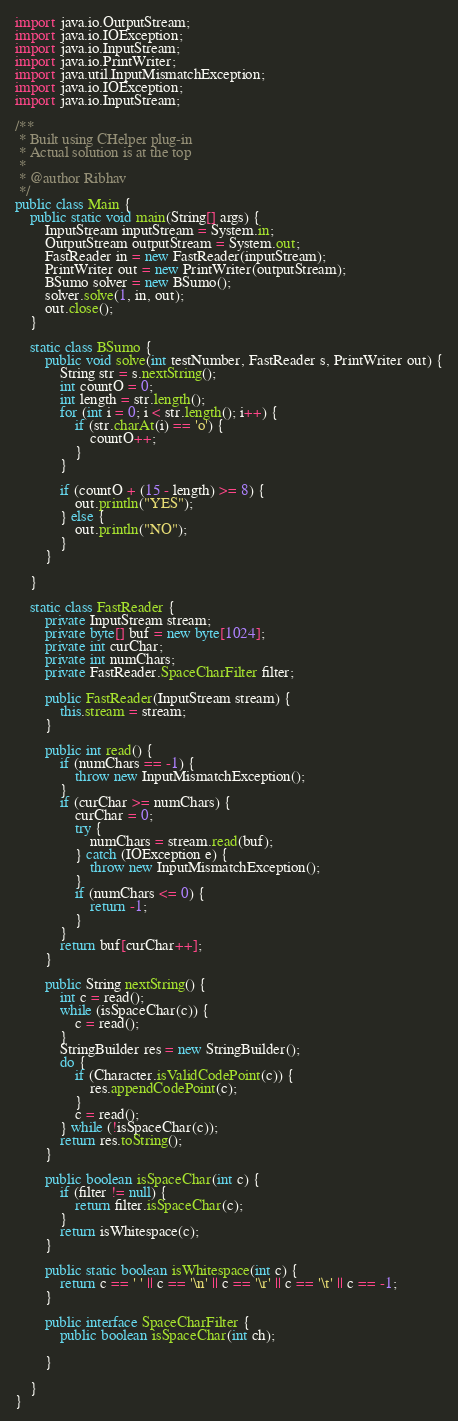Convert code to text. <code><loc_0><loc_0><loc_500><loc_500><_Java_>import java.io.OutputStream;
import java.io.IOException;
import java.io.InputStream;
import java.io.PrintWriter;
import java.util.InputMismatchException;
import java.io.IOException;
import java.io.InputStream;

/**
 * Built using CHelper plug-in
 * Actual solution is at the top
 *
 * @author Ribhav
 */
public class Main {
    public static void main(String[] args) {
        InputStream inputStream = System.in;
        OutputStream outputStream = System.out;
        FastReader in = new FastReader(inputStream);
        PrintWriter out = new PrintWriter(outputStream);
        BSumo solver = new BSumo();
        solver.solve(1, in, out);
        out.close();
    }

    static class BSumo {
        public void solve(int testNumber, FastReader s, PrintWriter out) {
            String str = s.nextString();
            int countO = 0;
            int length = str.length();
            for (int i = 0; i < str.length(); i++) {
                if (str.charAt(i) == 'o') {
                    countO++;
                }
            }

            if (countO + (15 - length) >= 8) {
                out.println("YES");
            } else {
                out.println("NO");
            }
        }

    }

    static class FastReader {
        private InputStream stream;
        private byte[] buf = new byte[1024];
        private int curChar;
        private int numChars;
        private FastReader.SpaceCharFilter filter;

        public FastReader(InputStream stream) {
            this.stream = stream;
        }

        public int read() {
            if (numChars == -1) {
                throw new InputMismatchException();
            }
            if (curChar >= numChars) {
                curChar = 0;
                try {
                    numChars = stream.read(buf);
                } catch (IOException e) {
                    throw new InputMismatchException();
                }
                if (numChars <= 0) {
                    return -1;
                }
            }
            return buf[curChar++];
        }

        public String nextString() {
            int c = read();
            while (isSpaceChar(c)) {
                c = read();
            }
            StringBuilder res = new StringBuilder();
            do {
                if (Character.isValidCodePoint(c)) {
                    res.appendCodePoint(c);
                }
                c = read();
            } while (!isSpaceChar(c));
            return res.toString();
        }

        public boolean isSpaceChar(int c) {
            if (filter != null) {
                return filter.isSpaceChar(c);
            }
            return isWhitespace(c);
        }

        public static boolean isWhitespace(int c) {
            return c == ' ' || c == '\n' || c == '\r' || c == '\t' || c == -1;
        }

        public interface SpaceCharFilter {
            public boolean isSpaceChar(int ch);

        }

    }
}

</code> 